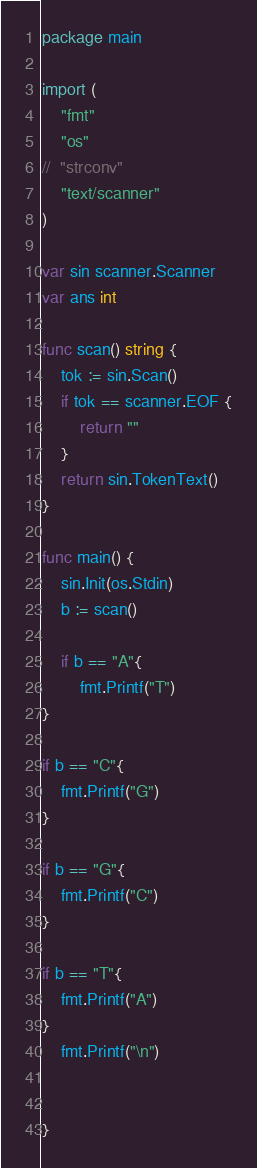Convert code to text. <code><loc_0><loc_0><loc_500><loc_500><_Go_>package main

import (
	"fmt"
	"os"
//	"strconv"
	"text/scanner"
)

var sin scanner.Scanner
var ans int

func scan() string {
	tok := sin.Scan()
	if tok == scanner.EOF {
		return ""
	}
	return sin.TokenText()
}

func main() {
	sin.Init(os.Stdin)
	b := scan()

	if b == "A"{
		fmt.Printf("T")
}

if b == "C"{
	fmt.Printf("G")
}

if b == "G"{
	fmt.Printf("C")
}

if b == "T"{
	fmt.Printf("A")
}
	fmt.Printf("\n")


}


</code> 